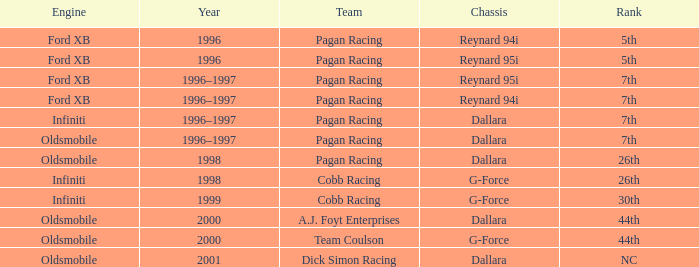What power source was used in 1999? Infiniti. 